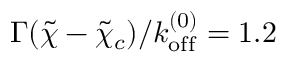<formula> <loc_0><loc_0><loc_500><loc_500>\Gamma ( \tilde { \chi } - \tilde { \chi } _ { c } ) / k _ { o f f } ^ { ( 0 ) } = 1 . 2</formula> 